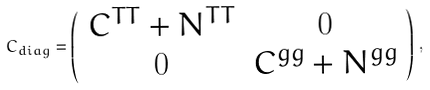<formula> <loc_0><loc_0><loc_500><loc_500>C _ { d i a g } = \left ( \begin{array} { c c } { C } ^ { T T } + { N } ^ { T T } & { 0 } \\ { 0 } & { C } ^ { g g } + { N } ^ { g g } \end{array} \right ) \, ,</formula> 